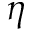Convert formula to latex. <formula><loc_0><loc_0><loc_500><loc_500>\eta</formula> 